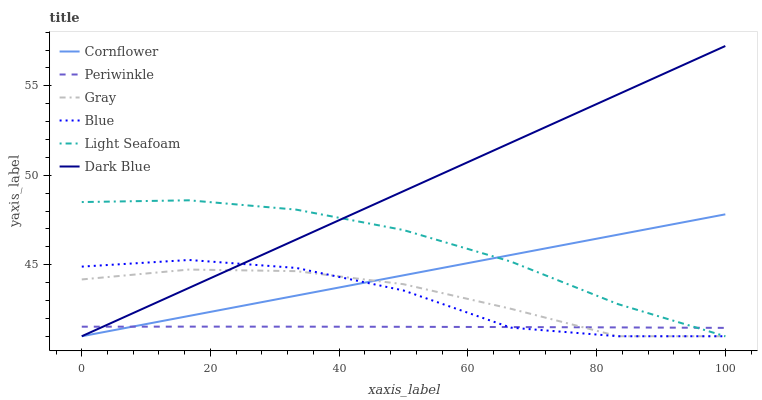Does Periwinkle have the minimum area under the curve?
Answer yes or no. Yes. Does Dark Blue have the maximum area under the curve?
Answer yes or no. Yes. Does Cornflower have the minimum area under the curve?
Answer yes or no. No. Does Cornflower have the maximum area under the curve?
Answer yes or no. No. Is Cornflower the smoothest?
Answer yes or no. Yes. Is Blue the roughest?
Answer yes or no. Yes. Is Gray the smoothest?
Answer yes or no. No. Is Gray the roughest?
Answer yes or no. No. Does Blue have the lowest value?
Answer yes or no. Yes. Does Periwinkle have the lowest value?
Answer yes or no. No. Does Dark Blue have the highest value?
Answer yes or no. Yes. Does Cornflower have the highest value?
Answer yes or no. No. Does Cornflower intersect Blue?
Answer yes or no. Yes. Is Cornflower less than Blue?
Answer yes or no. No. Is Cornflower greater than Blue?
Answer yes or no. No. 